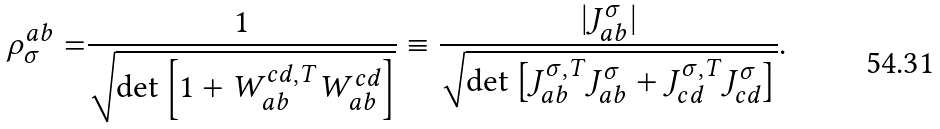<formula> <loc_0><loc_0><loc_500><loc_500>\rho _ { \sigma } ^ { a b } = & \frac { 1 } { \sqrt { \det \left [ 1 + W _ { a b } ^ { c d , T } W _ { a b } ^ { c d } \right ] } } \equiv \frac { | J _ { a b } ^ { \sigma } | } { \sqrt { \det \left [ J _ { a b } ^ { \sigma , T } J _ { a b } ^ { \sigma } + J _ { c d } ^ { \sigma , T } J _ { c d } ^ { \sigma } \right ] } } .</formula> 